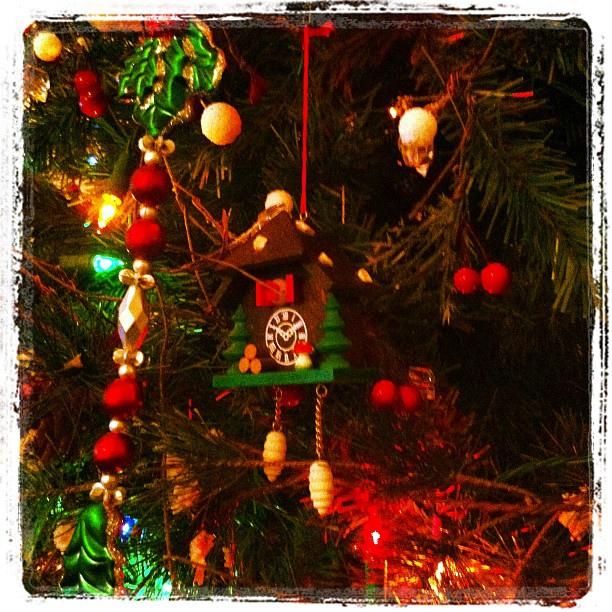Is there a bird's nest in this tree?
Concise answer only. No. Are there decorations on the tree?
Write a very short answer. Yes. What time of year is it?
Quick response, please. Christmas. 